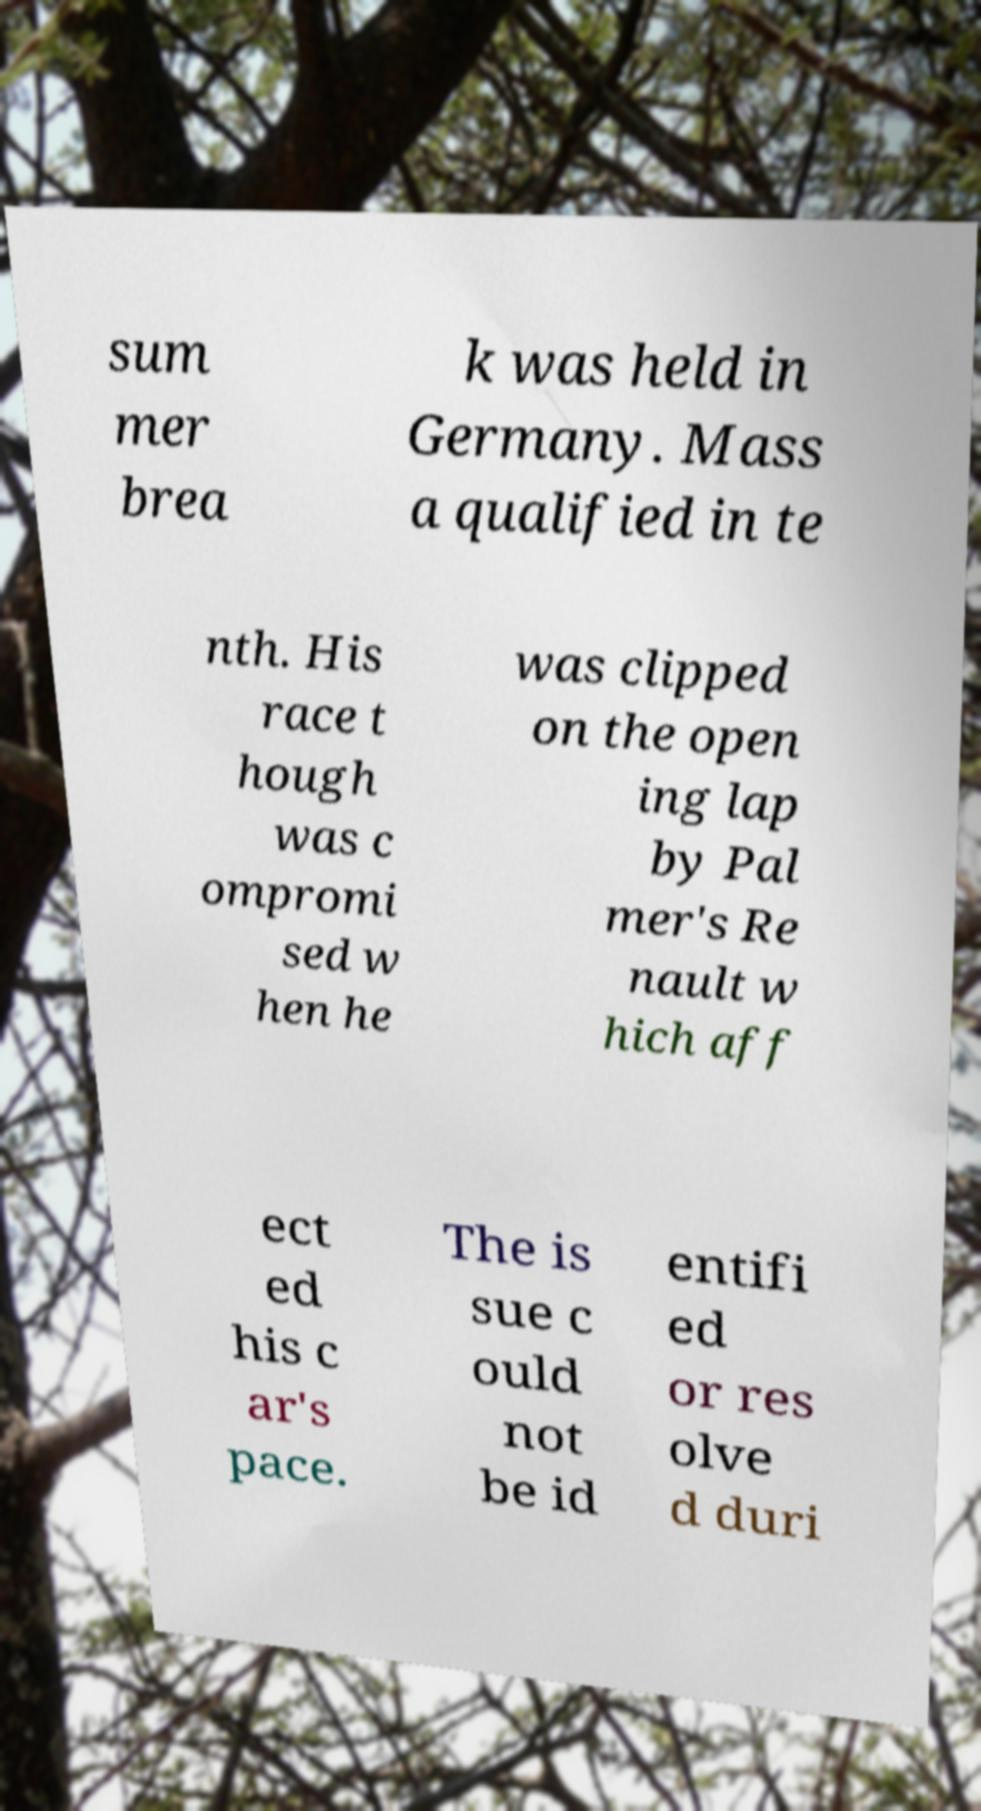Could you assist in decoding the text presented in this image and type it out clearly? sum mer brea k was held in Germany. Mass a qualified in te nth. His race t hough was c ompromi sed w hen he was clipped on the open ing lap by Pal mer's Re nault w hich aff ect ed his c ar's pace. The is sue c ould not be id entifi ed or res olve d duri 